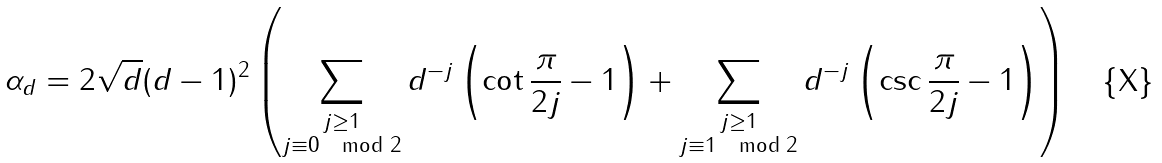<formula> <loc_0><loc_0><loc_500><loc_500>\alpha _ { d } = 2 \sqrt { d } ( d - 1 ) ^ { 2 } \left ( \sum _ { \substack { j \geq 1 \\ j \equiv 0 \mod 2 } } d ^ { - j } \left ( \cot \frac { \pi } { 2 j } - 1 \right ) + \sum _ { \substack { j \geq 1 \\ j \equiv 1 \mod 2 } } d ^ { - j } \left ( \csc \frac { \pi } { 2 j } - 1 \right ) \right )</formula> 